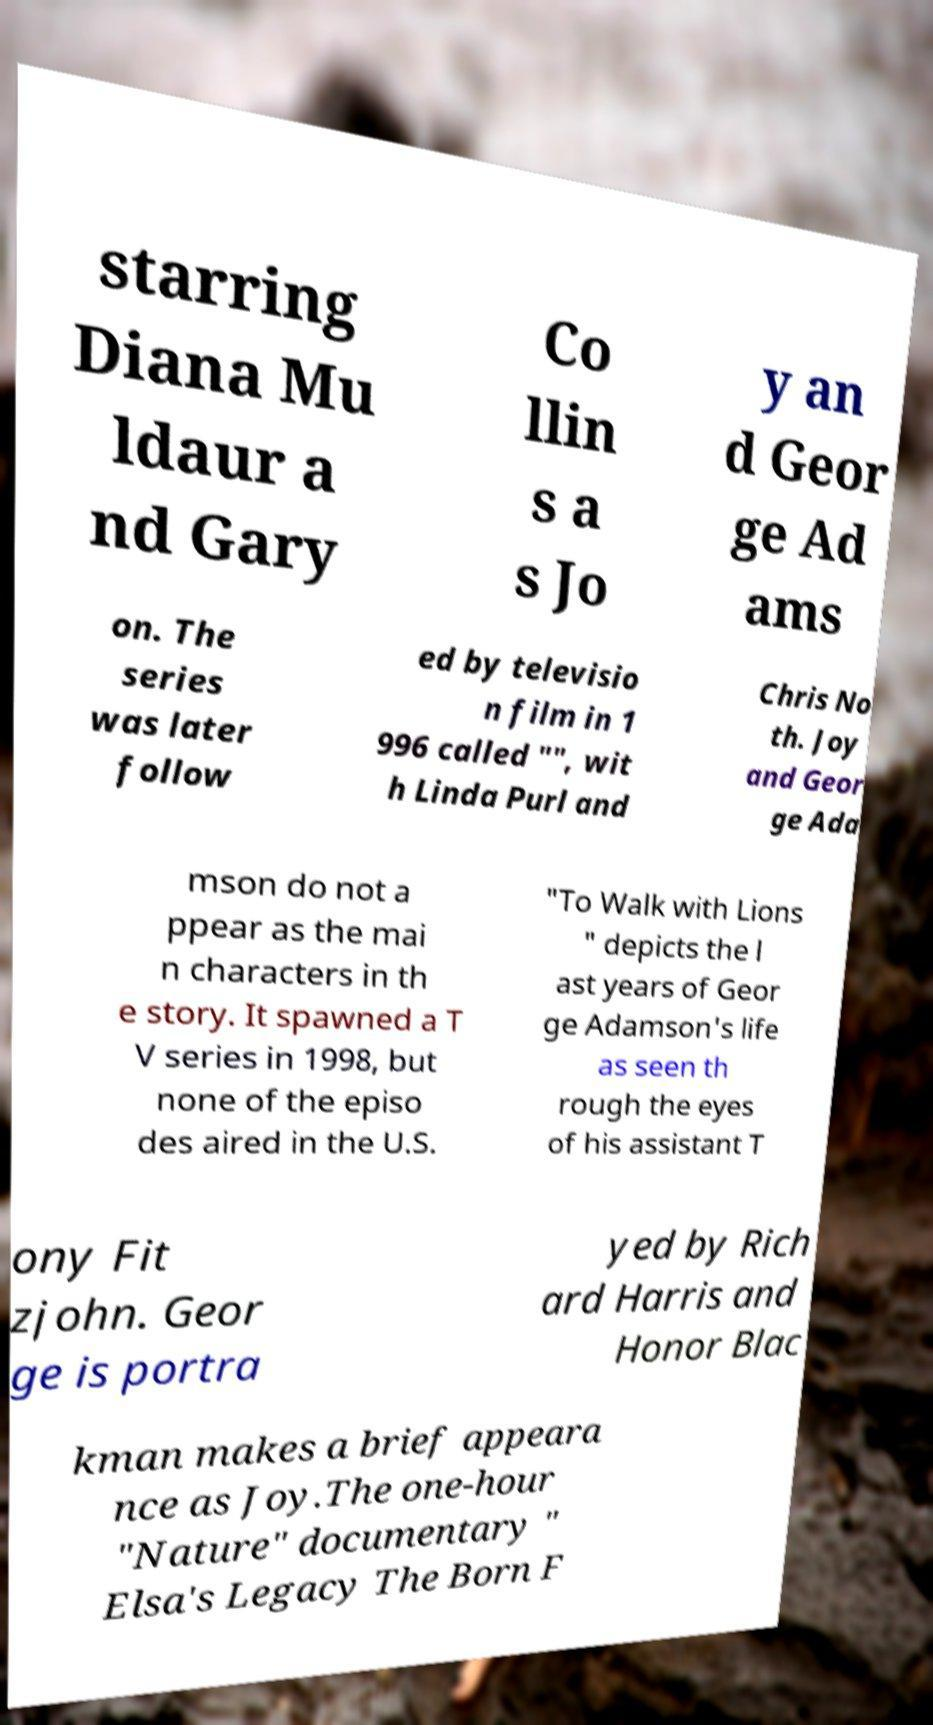Could you assist in decoding the text presented in this image and type it out clearly? starring Diana Mu ldaur a nd Gary Co llin s a s Jo y an d Geor ge Ad ams on. The series was later follow ed by televisio n film in 1 996 called "", wit h Linda Purl and Chris No th. Joy and Geor ge Ada mson do not a ppear as the mai n characters in th e story. It spawned a T V series in 1998, but none of the episo des aired in the U.S. "To Walk with Lions " depicts the l ast years of Geor ge Adamson's life as seen th rough the eyes of his assistant T ony Fit zjohn. Geor ge is portra yed by Rich ard Harris and Honor Blac kman makes a brief appeara nce as Joy.The one-hour "Nature" documentary " Elsa's Legacy The Born F 